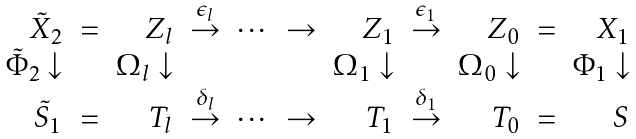Convert formula to latex. <formula><loc_0><loc_0><loc_500><loc_500>\begin{array} { r r r r r r r r r r r } \tilde { X } _ { 2 } & = & Z _ { l } & \stackrel { \epsilon _ { l } } { \rightarrow } & \cdots & \rightarrow & Z _ { 1 } & \stackrel { \epsilon _ { 1 } } { \rightarrow } & Z _ { 0 } & = & X _ { 1 } \\ \tilde { \Phi } _ { 2 } \downarrow & & \Omega _ { l } \downarrow & & & & \Omega _ { 1 } \downarrow & & \Omega _ { 0 } \downarrow & & \Phi _ { 1 } \downarrow \\ \tilde { S } _ { 1 } & = & T _ { l } & \stackrel { \delta _ { l } } { \rightarrow } & \cdots & \rightarrow & T _ { 1 } & \stackrel { \delta _ { 1 } } { \rightarrow } & T _ { 0 } & = & S \end{array}</formula> 